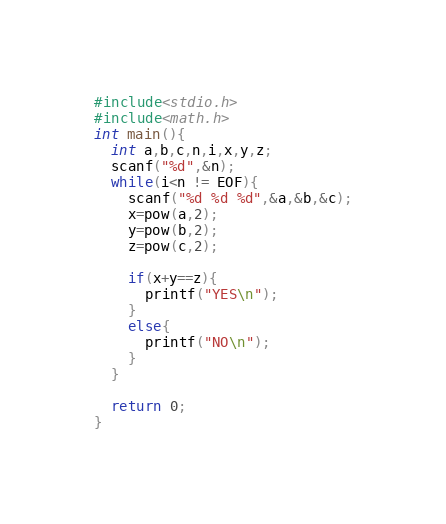<code> <loc_0><loc_0><loc_500><loc_500><_C_>#include<stdio.h>
#include<math.h>
int main(){
  int a,b,c,n,i,x,y,z;
  scanf("%d",&n);
  while(i<n != EOF){
    scanf("%d %d %d",&a,&b,&c);
    x=pow(a,2);
    y=pow(b,2);
    z=pow(c,2);

    if(x+y==z){
      printf("YES\n");
    }
    else{
      printf("NO\n");
    }
  }

  return 0;
}</code> 